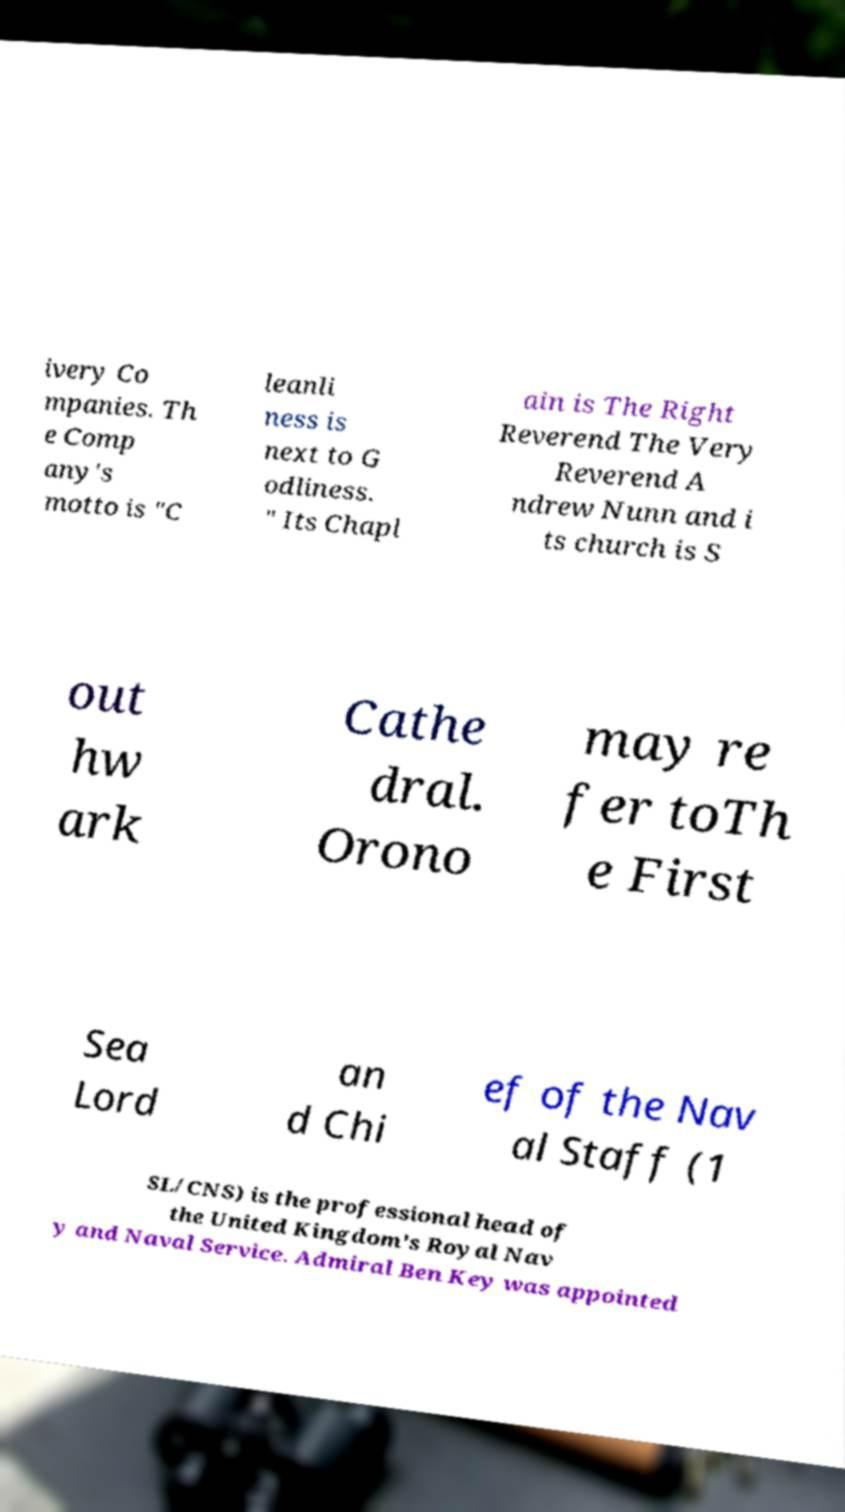What messages or text are displayed in this image? I need them in a readable, typed format. ivery Co mpanies. Th e Comp any's motto is "C leanli ness is next to G odliness. " Its Chapl ain is The Right Reverend The Very Reverend A ndrew Nunn and i ts church is S out hw ark Cathe dral. Orono may re fer toTh e First Sea Lord an d Chi ef of the Nav al Staff (1 SL/CNS) is the professional head of the United Kingdom's Royal Nav y and Naval Service. Admiral Ben Key was appointed 